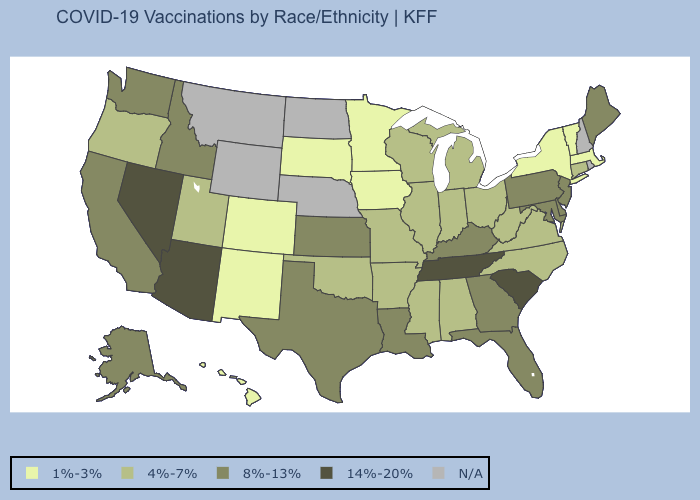Which states have the highest value in the USA?
Quick response, please. Arizona, Nevada, South Carolina, Tennessee. Which states have the highest value in the USA?
Write a very short answer. Arizona, Nevada, South Carolina, Tennessee. What is the lowest value in the USA?
Answer briefly. 1%-3%. Does Indiana have the lowest value in the USA?
Write a very short answer. No. How many symbols are there in the legend?
Give a very brief answer. 5. Name the states that have a value in the range 8%-13%?
Answer briefly. Alaska, California, Delaware, Florida, Georgia, Idaho, Kansas, Kentucky, Louisiana, Maine, Maryland, New Jersey, Pennsylvania, Texas, Washington. Does Tennessee have the highest value in the USA?
Concise answer only. Yes. Does the first symbol in the legend represent the smallest category?
Keep it brief. Yes. Which states hav the highest value in the South?
Give a very brief answer. South Carolina, Tennessee. Does the map have missing data?
Concise answer only. Yes. What is the highest value in states that border Alabama?
Answer briefly. 14%-20%. What is the value of Florida?
Short answer required. 8%-13%. 